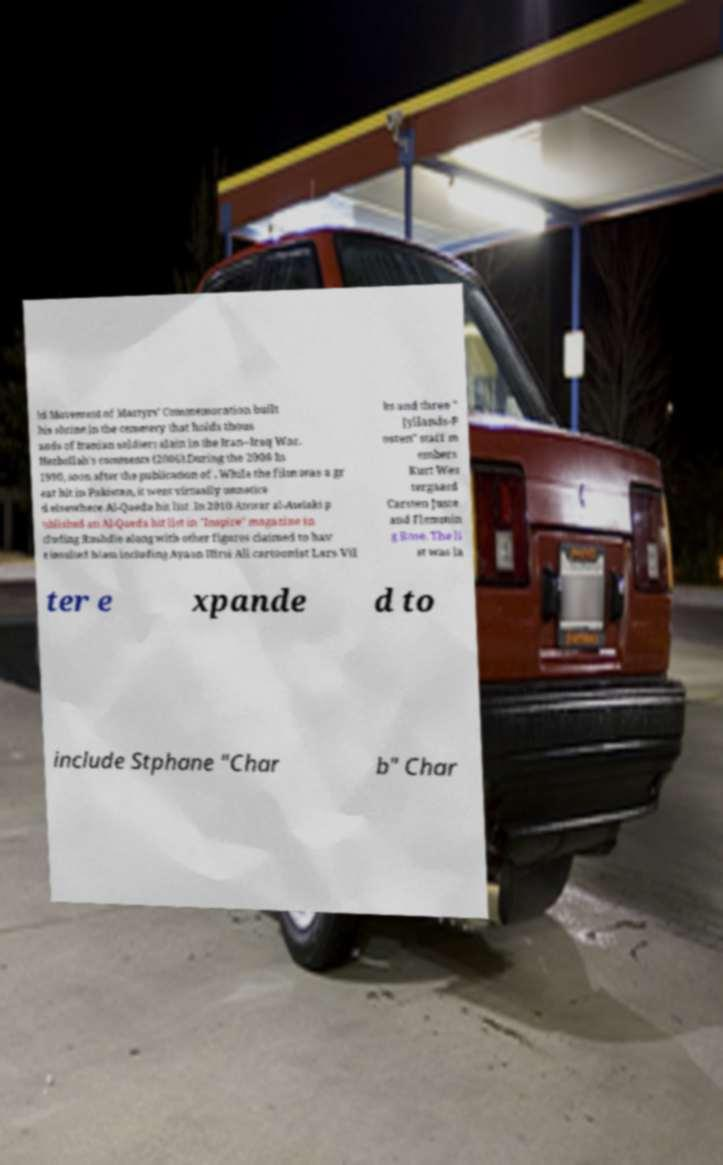Could you extract and type out the text from this image? ld Movement of Martyrs' Commemoration built his shrine in the cemetery that holds thous ands of Iranian soldiers slain in the Iran–Iraq War. Hezbollah's comments (2006).During the 2006 In 1990, soon after the publication of . While the film was a gr eat hit in Pakistan, it went virtually unnotice d elsewhere.Al-Qaeda hit list .In 2010 Anwar al-Awlaki p ublished an Al-Qaeda hit list in "Inspire" magazine in cluding Rushdie along with other figures claimed to hav e insulted Islam including Ayaan Hirsi Ali cartoonist Lars Vil ks and three " Jyllands-P osten" staff m embers Kurt Wes tergaard Carsten Juste and Flemmin g Rose. The li st was la ter e xpande d to include Stphane "Char b" Char 